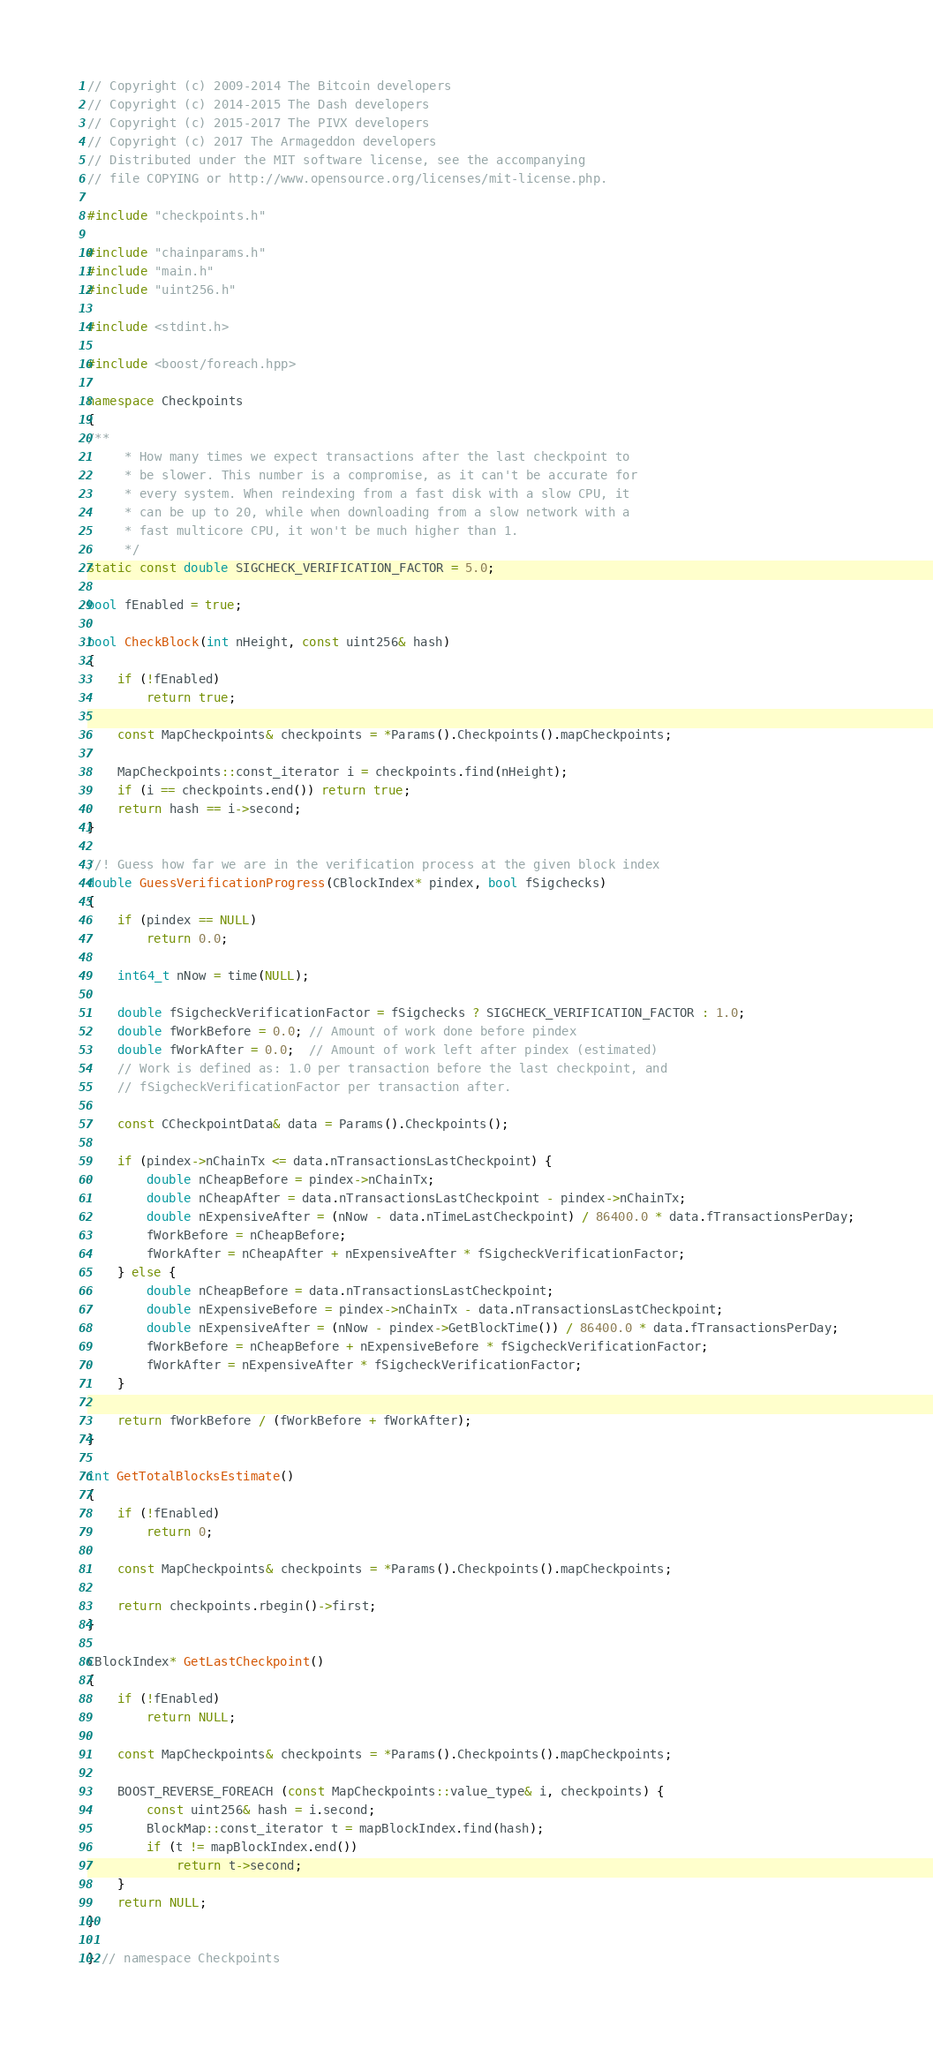<code> <loc_0><loc_0><loc_500><loc_500><_C++_>// Copyright (c) 2009-2014 The Bitcoin developers
// Copyright (c) 2014-2015 The Dash developers
// Copyright (c) 2015-2017 The PIVX developers
// Copyright (c) 2017 The Armageddon developers
// Distributed under the MIT software license, see the accompanying
// file COPYING or http://www.opensource.org/licenses/mit-license.php.

#include "checkpoints.h"

#include "chainparams.h"
#include "main.h"
#include "uint256.h"

#include <stdint.h>

#include <boost/foreach.hpp>

namespace Checkpoints
{
/**
     * How many times we expect transactions after the last checkpoint to
     * be slower. This number is a compromise, as it can't be accurate for
     * every system. When reindexing from a fast disk with a slow CPU, it
     * can be up to 20, while when downloading from a slow network with a
     * fast multicore CPU, it won't be much higher than 1.
     */
static const double SIGCHECK_VERIFICATION_FACTOR = 5.0;

bool fEnabled = true;

bool CheckBlock(int nHeight, const uint256& hash)
{
    if (!fEnabled)
        return true;

    const MapCheckpoints& checkpoints = *Params().Checkpoints().mapCheckpoints;

    MapCheckpoints::const_iterator i = checkpoints.find(nHeight);
    if (i == checkpoints.end()) return true;
    return hash == i->second;
}

//! Guess how far we are in the verification process at the given block index
double GuessVerificationProgress(CBlockIndex* pindex, bool fSigchecks)
{
    if (pindex == NULL)
        return 0.0;

    int64_t nNow = time(NULL);

    double fSigcheckVerificationFactor = fSigchecks ? SIGCHECK_VERIFICATION_FACTOR : 1.0;
    double fWorkBefore = 0.0; // Amount of work done before pindex
    double fWorkAfter = 0.0;  // Amount of work left after pindex (estimated)
    // Work is defined as: 1.0 per transaction before the last checkpoint, and
    // fSigcheckVerificationFactor per transaction after.

    const CCheckpointData& data = Params().Checkpoints();

    if (pindex->nChainTx <= data.nTransactionsLastCheckpoint) {
        double nCheapBefore = pindex->nChainTx;
        double nCheapAfter = data.nTransactionsLastCheckpoint - pindex->nChainTx;
        double nExpensiveAfter = (nNow - data.nTimeLastCheckpoint) / 86400.0 * data.fTransactionsPerDay;
        fWorkBefore = nCheapBefore;
        fWorkAfter = nCheapAfter + nExpensiveAfter * fSigcheckVerificationFactor;
    } else {
        double nCheapBefore = data.nTransactionsLastCheckpoint;
        double nExpensiveBefore = pindex->nChainTx - data.nTransactionsLastCheckpoint;
        double nExpensiveAfter = (nNow - pindex->GetBlockTime()) / 86400.0 * data.fTransactionsPerDay;
        fWorkBefore = nCheapBefore + nExpensiveBefore * fSigcheckVerificationFactor;
        fWorkAfter = nExpensiveAfter * fSigcheckVerificationFactor;
    }

    return fWorkBefore / (fWorkBefore + fWorkAfter);
}

int GetTotalBlocksEstimate()
{
    if (!fEnabled)
        return 0;

    const MapCheckpoints& checkpoints = *Params().Checkpoints().mapCheckpoints;

    return checkpoints.rbegin()->first;
}

CBlockIndex* GetLastCheckpoint()
{
    if (!fEnabled)
        return NULL;

    const MapCheckpoints& checkpoints = *Params().Checkpoints().mapCheckpoints;

    BOOST_REVERSE_FOREACH (const MapCheckpoints::value_type& i, checkpoints) {
        const uint256& hash = i.second;
        BlockMap::const_iterator t = mapBlockIndex.find(hash);
        if (t != mapBlockIndex.end())
            return t->second;
    }
    return NULL;
}

} // namespace Checkpoints
</code> 